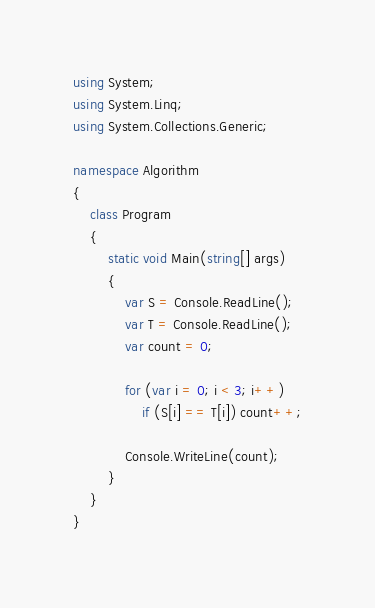Convert code to text. <code><loc_0><loc_0><loc_500><loc_500><_C#_>using System;
using System.Linq;
using System.Collections.Generic;

namespace Algorithm
{
    class Program
    {
        static void Main(string[] args)
        {
            var S = Console.ReadLine();
            var T = Console.ReadLine();
            var count = 0;

            for (var i = 0; i < 3; i++)
                if (S[i] == T[i]) count++;

            Console.WriteLine(count);
        }
    }
}
</code> 